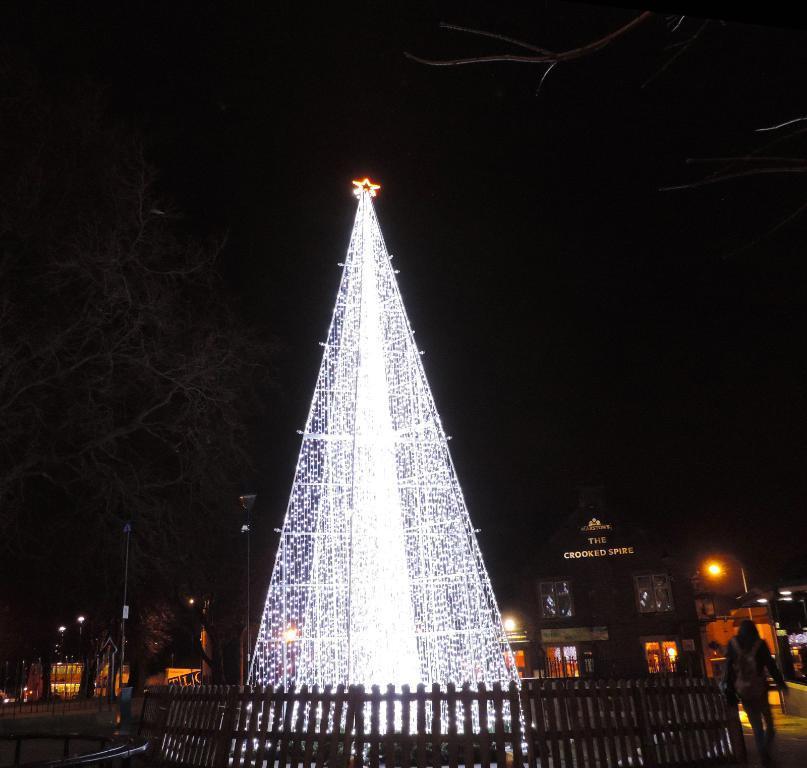In one or two sentences, can you explain what this image depicts? In the center of the image we can see the lights. In the background of the image we can see the trees, poles, lights, boards, stores. In the bottom right corner we can see a person is walking on the road and wearing a bag. At the bottom of the image we can see the fence and the road. At the top of the image we can see the sky. 